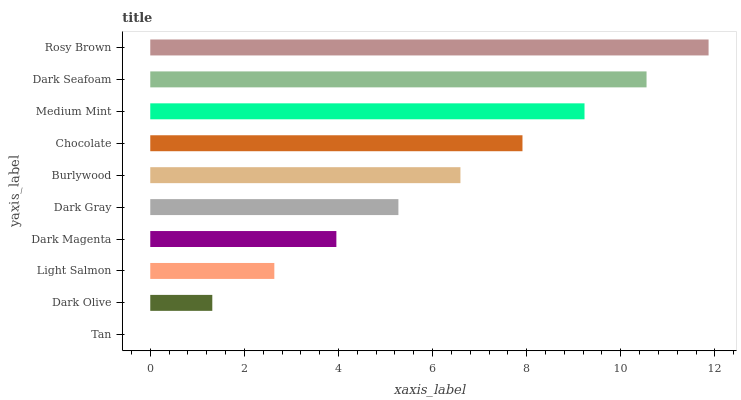Is Tan the minimum?
Answer yes or no. Yes. Is Rosy Brown the maximum?
Answer yes or no. Yes. Is Dark Olive the minimum?
Answer yes or no. No. Is Dark Olive the maximum?
Answer yes or no. No. Is Dark Olive greater than Tan?
Answer yes or no. Yes. Is Tan less than Dark Olive?
Answer yes or no. Yes. Is Tan greater than Dark Olive?
Answer yes or no. No. Is Dark Olive less than Tan?
Answer yes or no. No. Is Burlywood the high median?
Answer yes or no. Yes. Is Dark Gray the low median?
Answer yes or no. Yes. Is Light Salmon the high median?
Answer yes or no. No. Is Rosy Brown the low median?
Answer yes or no. No. 